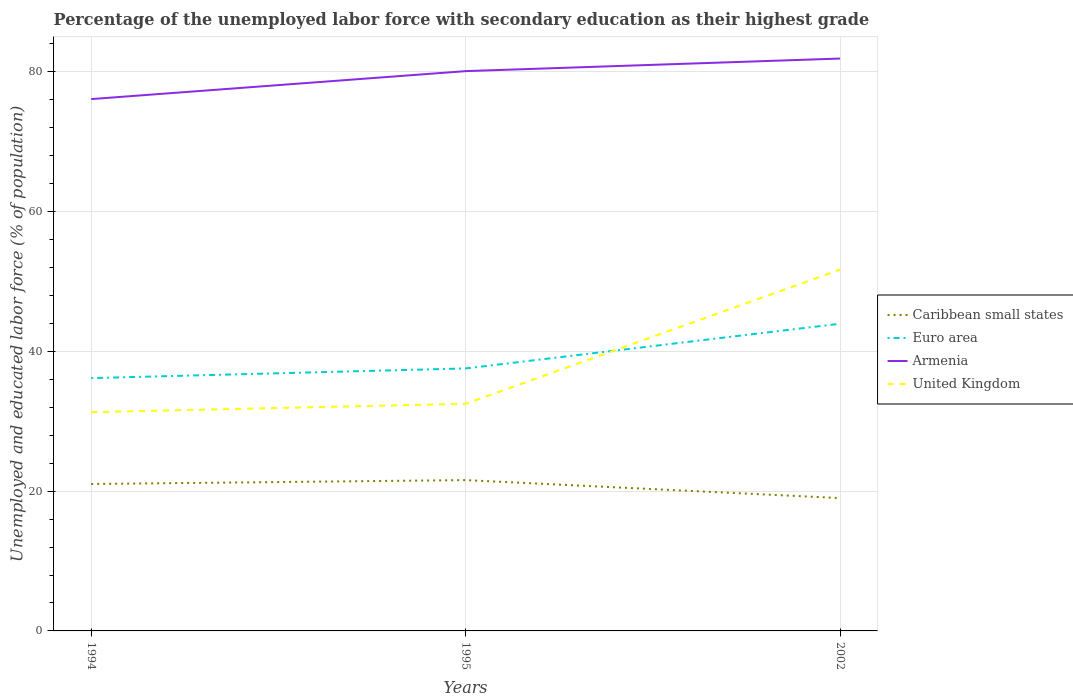Across all years, what is the maximum percentage of the unemployed labor force with secondary education in United Kingdom?
Ensure brevity in your answer.  31.3. What is the total percentage of the unemployed labor force with secondary education in Euro area in the graph?
Offer a very short reply. -1.38. What is the difference between the highest and the second highest percentage of the unemployed labor force with secondary education in Armenia?
Make the answer very short. 5.8. How many lines are there?
Keep it short and to the point. 4. How many years are there in the graph?
Your answer should be compact. 3. Does the graph contain any zero values?
Your response must be concise. No. How many legend labels are there?
Keep it short and to the point. 4. What is the title of the graph?
Your answer should be compact. Percentage of the unemployed labor force with secondary education as their highest grade. What is the label or title of the Y-axis?
Your answer should be very brief. Unemployed and educated labor force (% of population). What is the Unemployed and educated labor force (% of population) in Caribbean small states in 1994?
Your response must be concise. 21.02. What is the Unemployed and educated labor force (% of population) of Euro area in 1994?
Your answer should be very brief. 36.18. What is the Unemployed and educated labor force (% of population) of Armenia in 1994?
Give a very brief answer. 76.1. What is the Unemployed and educated labor force (% of population) in United Kingdom in 1994?
Offer a very short reply. 31.3. What is the Unemployed and educated labor force (% of population) of Caribbean small states in 1995?
Provide a succinct answer. 21.58. What is the Unemployed and educated labor force (% of population) in Euro area in 1995?
Ensure brevity in your answer.  37.56. What is the Unemployed and educated labor force (% of population) of Armenia in 1995?
Provide a succinct answer. 80.1. What is the Unemployed and educated labor force (% of population) of United Kingdom in 1995?
Give a very brief answer. 32.5. What is the Unemployed and educated labor force (% of population) of Caribbean small states in 2002?
Provide a short and direct response. 19.01. What is the Unemployed and educated labor force (% of population) in Euro area in 2002?
Give a very brief answer. 43.96. What is the Unemployed and educated labor force (% of population) of Armenia in 2002?
Your response must be concise. 81.9. What is the Unemployed and educated labor force (% of population) in United Kingdom in 2002?
Give a very brief answer. 51.7. Across all years, what is the maximum Unemployed and educated labor force (% of population) in Caribbean small states?
Give a very brief answer. 21.58. Across all years, what is the maximum Unemployed and educated labor force (% of population) of Euro area?
Offer a terse response. 43.96. Across all years, what is the maximum Unemployed and educated labor force (% of population) of Armenia?
Offer a very short reply. 81.9. Across all years, what is the maximum Unemployed and educated labor force (% of population) of United Kingdom?
Keep it short and to the point. 51.7. Across all years, what is the minimum Unemployed and educated labor force (% of population) of Caribbean small states?
Your response must be concise. 19.01. Across all years, what is the minimum Unemployed and educated labor force (% of population) in Euro area?
Provide a succinct answer. 36.18. Across all years, what is the minimum Unemployed and educated labor force (% of population) in Armenia?
Your answer should be very brief. 76.1. Across all years, what is the minimum Unemployed and educated labor force (% of population) in United Kingdom?
Ensure brevity in your answer.  31.3. What is the total Unemployed and educated labor force (% of population) of Caribbean small states in the graph?
Keep it short and to the point. 61.61. What is the total Unemployed and educated labor force (% of population) of Euro area in the graph?
Your answer should be very brief. 117.69. What is the total Unemployed and educated labor force (% of population) in Armenia in the graph?
Make the answer very short. 238.1. What is the total Unemployed and educated labor force (% of population) in United Kingdom in the graph?
Your answer should be compact. 115.5. What is the difference between the Unemployed and educated labor force (% of population) in Caribbean small states in 1994 and that in 1995?
Provide a short and direct response. -0.55. What is the difference between the Unemployed and educated labor force (% of population) of Euro area in 1994 and that in 1995?
Give a very brief answer. -1.38. What is the difference between the Unemployed and educated labor force (% of population) of United Kingdom in 1994 and that in 1995?
Ensure brevity in your answer.  -1.2. What is the difference between the Unemployed and educated labor force (% of population) of Caribbean small states in 1994 and that in 2002?
Offer a very short reply. 2.02. What is the difference between the Unemployed and educated labor force (% of population) of Euro area in 1994 and that in 2002?
Your response must be concise. -7.78. What is the difference between the Unemployed and educated labor force (% of population) of United Kingdom in 1994 and that in 2002?
Make the answer very short. -20.4. What is the difference between the Unemployed and educated labor force (% of population) in Caribbean small states in 1995 and that in 2002?
Ensure brevity in your answer.  2.57. What is the difference between the Unemployed and educated labor force (% of population) of Euro area in 1995 and that in 2002?
Give a very brief answer. -6.4. What is the difference between the Unemployed and educated labor force (% of population) of United Kingdom in 1995 and that in 2002?
Offer a very short reply. -19.2. What is the difference between the Unemployed and educated labor force (% of population) of Caribbean small states in 1994 and the Unemployed and educated labor force (% of population) of Euro area in 1995?
Provide a succinct answer. -16.54. What is the difference between the Unemployed and educated labor force (% of population) of Caribbean small states in 1994 and the Unemployed and educated labor force (% of population) of Armenia in 1995?
Your answer should be very brief. -59.08. What is the difference between the Unemployed and educated labor force (% of population) of Caribbean small states in 1994 and the Unemployed and educated labor force (% of population) of United Kingdom in 1995?
Make the answer very short. -11.48. What is the difference between the Unemployed and educated labor force (% of population) of Euro area in 1994 and the Unemployed and educated labor force (% of population) of Armenia in 1995?
Offer a terse response. -43.92. What is the difference between the Unemployed and educated labor force (% of population) of Euro area in 1994 and the Unemployed and educated labor force (% of population) of United Kingdom in 1995?
Your answer should be very brief. 3.68. What is the difference between the Unemployed and educated labor force (% of population) in Armenia in 1994 and the Unemployed and educated labor force (% of population) in United Kingdom in 1995?
Ensure brevity in your answer.  43.6. What is the difference between the Unemployed and educated labor force (% of population) in Caribbean small states in 1994 and the Unemployed and educated labor force (% of population) in Euro area in 2002?
Offer a terse response. -22.93. What is the difference between the Unemployed and educated labor force (% of population) of Caribbean small states in 1994 and the Unemployed and educated labor force (% of population) of Armenia in 2002?
Make the answer very short. -60.88. What is the difference between the Unemployed and educated labor force (% of population) of Caribbean small states in 1994 and the Unemployed and educated labor force (% of population) of United Kingdom in 2002?
Keep it short and to the point. -30.68. What is the difference between the Unemployed and educated labor force (% of population) in Euro area in 1994 and the Unemployed and educated labor force (% of population) in Armenia in 2002?
Provide a short and direct response. -45.72. What is the difference between the Unemployed and educated labor force (% of population) in Euro area in 1994 and the Unemployed and educated labor force (% of population) in United Kingdom in 2002?
Keep it short and to the point. -15.52. What is the difference between the Unemployed and educated labor force (% of population) of Armenia in 1994 and the Unemployed and educated labor force (% of population) of United Kingdom in 2002?
Provide a short and direct response. 24.4. What is the difference between the Unemployed and educated labor force (% of population) in Caribbean small states in 1995 and the Unemployed and educated labor force (% of population) in Euro area in 2002?
Your answer should be very brief. -22.38. What is the difference between the Unemployed and educated labor force (% of population) of Caribbean small states in 1995 and the Unemployed and educated labor force (% of population) of Armenia in 2002?
Offer a very short reply. -60.32. What is the difference between the Unemployed and educated labor force (% of population) of Caribbean small states in 1995 and the Unemployed and educated labor force (% of population) of United Kingdom in 2002?
Provide a succinct answer. -30.12. What is the difference between the Unemployed and educated labor force (% of population) in Euro area in 1995 and the Unemployed and educated labor force (% of population) in Armenia in 2002?
Your answer should be very brief. -44.34. What is the difference between the Unemployed and educated labor force (% of population) of Euro area in 1995 and the Unemployed and educated labor force (% of population) of United Kingdom in 2002?
Your answer should be compact. -14.14. What is the difference between the Unemployed and educated labor force (% of population) of Armenia in 1995 and the Unemployed and educated labor force (% of population) of United Kingdom in 2002?
Make the answer very short. 28.4. What is the average Unemployed and educated labor force (% of population) of Caribbean small states per year?
Your response must be concise. 20.54. What is the average Unemployed and educated labor force (% of population) of Euro area per year?
Provide a short and direct response. 39.23. What is the average Unemployed and educated labor force (% of population) of Armenia per year?
Give a very brief answer. 79.37. What is the average Unemployed and educated labor force (% of population) in United Kingdom per year?
Your answer should be compact. 38.5. In the year 1994, what is the difference between the Unemployed and educated labor force (% of population) of Caribbean small states and Unemployed and educated labor force (% of population) of Euro area?
Provide a short and direct response. -15.15. In the year 1994, what is the difference between the Unemployed and educated labor force (% of population) in Caribbean small states and Unemployed and educated labor force (% of population) in Armenia?
Ensure brevity in your answer.  -55.08. In the year 1994, what is the difference between the Unemployed and educated labor force (% of population) of Caribbean small states and Unemployed and educated labor force (% of population) of United Kingdom?
Your response must be concise. -10.28. In the year 1994, what is the difference between the Unemployed and educated labor force (% of population) of Euro area and Unemployed and educated labor force (% of population) of Armenia?
Offer a terse response. -39.92. In the year 1994, what is the difference between the Unemployed and educated labor force (% of population) of Euro area and Unemployed and educated labor force (% of population) of United Kingdom?
Make the answer very short. 4.88. In the year 1994, what is the difference between the Unemployed and educated labor force (% of population) of Armenia and Unemployed and educated labor force (% of population) of United Kingdom?
Your response must be concise. 44.8. In the year 1995, what is the difference between the Unemployed and educated labor force (% of population) in Caribbean small states and Unemployed and educated labor force (% of population) in Euro area?
Keep it short and to the point. -15.98. In the year 1995, what is the difference between the Unemployed and educated labor force (% of population) in Caribbean small states and Unemployed and educated labor force (% of population) in Armenia?
Offer a very short reply. -58.52. In the year 1995, what is the difference between the Unemployed and educated labor force (% of population) in Caribbean small states and Unemployed and educated labor force (% of population) in United Kingdom?
Your answer should be compact. -10.92. In the year 1995, what is the difference between the Unemployed and educated labor force (% of population) in Euro area and Unemployed and educated labor force (% of population) in Armenia?
Provide a short and direct response. -42.54. In the year 1995, what is the difference between the Unemployed and educated labor force (% of population) of Euro area and Unemployed and educated labor force (% of population) of United Kingdom?
Ensure brevity in your answer.  5.06. In the year 1995, what is the difference between the Unemployed and educated labor force (% of population) of Armenia and Unemployed and educated labor force (% of population) of United Kingdom?
Provide a succinct answer. 47.6. In the year 2002, what is the difference between the Unemployed and educated labor force (% of population) of Caribbean small states and Unemployed and educated labor force (% of population) of Euro area?
Offer a terse response. -24.95. In the year 2002, what is the difference between the Unemployed and educated labor force (% of population) of Caribbean small states and Unemployed and educated labor force (% of population) of Armenia?
Provide a short and direct response. -62.89. In the year 2002, what is the difference between the Unemployed and educated labor force (% of population) of Caribbean small states and Unemployed and educated labor force (% of population) of United Kingdom?
Offer a terse response. -32.69. In the year 2002, what is the difference between the Unemployed and educated labor force (% of population) of Euro area and Unemployed and educated labor force (% of population) of Armenia?
Your response must be concise. -37.94. In the year 2002, what is the difference between the Unemployed and educated labor force (% of population) in Euro area and Unemployed and educated labor force (% of population) in United Kingdom?
Your response must be concise. -7.74. In the year 2002, what is the difference between the Unemployed and educated labor force (% of population) in Armenia and Unemployed and educated labor force (% of population) in United Kingdom?
Offer a terse response. 30.2. What is the ratio of the Unemployed and educated labor force (% of population) in Caribbean small states in 1994 to that in 1995?
Make the answer very short. 0.97. What is the ratio of the Unemployed and educated labor force (% of population) in Euro area in 1994 to that in 1995?
Provide a short and direct response. 0.96. What is the ratio of the Unemployed and educated labor force (% of population) in Armenia in 1994 to that in 1995?
Your answer should be very brief. 0.95. What is the ratio of the Unemployed and educated labor force (% of population) of United Kingdom in 1994 to that in 1995?
Give a very brief answer. 0.96. What is the ratio of the Unemployed and educated labor force (% of population) in Caribbean small states in 1994 to that in 2002?
Provide a short and direct response. 1.11. What is the ratio of the Unemployed and educated labor force (% of population) in Euro area in 1994 to that in 2002?
Offer a terse response. 0.82. What is the ratio of the Unemployed and educated labor force (% of population) of Armenia in 1994 to that in 2002?
Keep it short and to the point. 0.93. What is the ratio of the Unemployed and educated labor force (% of population) of United Kingdom in 1994 to that in 2002?
Your answer should be very brief. 0.61. What is the ratio of the Unemployed and educated labor force (% of population) in Caribbean small states in 1995 to that in 2002?
Keep it short and to the point. 1.14. What is the ratio of the Unemployed and educated labor force (% of population) of Euro area in 1995 to that in 2002?
Your response must be concise. 0.85. What is the ratio of the Unemployed and educated labor force (% of population) of United Kingdom in 1995 to that in 2002?
Provide a short and direct response. 0.63. What is the difference between the highest and the second highest Unemployed and educated labor force (% of population) in Caribbean small states?
Your answer should be compact. 0.55. What is the difference between the highest and the second highest Unemployed and educated labor force (% of population) of Euro area?
Make the answer very short. 6.4. What is the difference between the highest and the second highest Unemployed and educated labor force (% of population) in Armenia?
Give a very brief answer. 1.8. What is the difference between the highest and the lowest Unemployed and educated labor force (% of population) in Caribbean small states?
Provide a short and direct response. 2.57. What is the difference between the highest and the lowest Unemployed and educated labor force (% of population) of Euro area?
Your answer should be very brief. 7.78. What is the difference between the highest and the lowest Unemployed and educated labor force (% of population) in Armenia?
Provide a succinct answer. 5.8. What is the difference between the highest and the lowest Unemployed and educated labor force (% of population) of United Kingdom?
Make the answer very short. 20.4. 